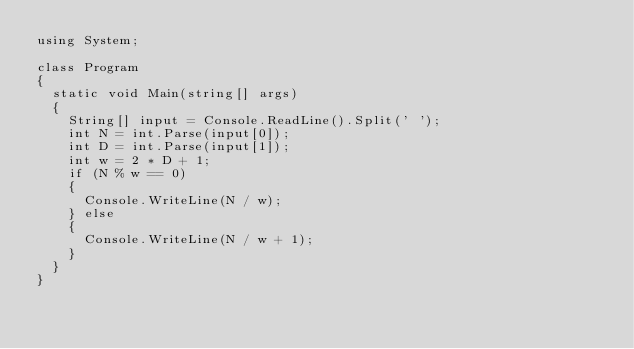Convert code to text. <code><loc_0><loc_0><loc_500><loc_500><_C#_>using System;

class Program
{
  static void Main(string[] args)
  {
    String[] input = Console.ReadLine().Split(' ');
    int N = int.Parse(input[0]);
    int D = int.Parse(input[1]);
    int w = 2 * D + 1;
    if (N % w == 0)
    {
      Console.WriteLine(N / w);
    } else
    {
      Console.WriteLine(N / w + 1);
    }
  }
}</code> 